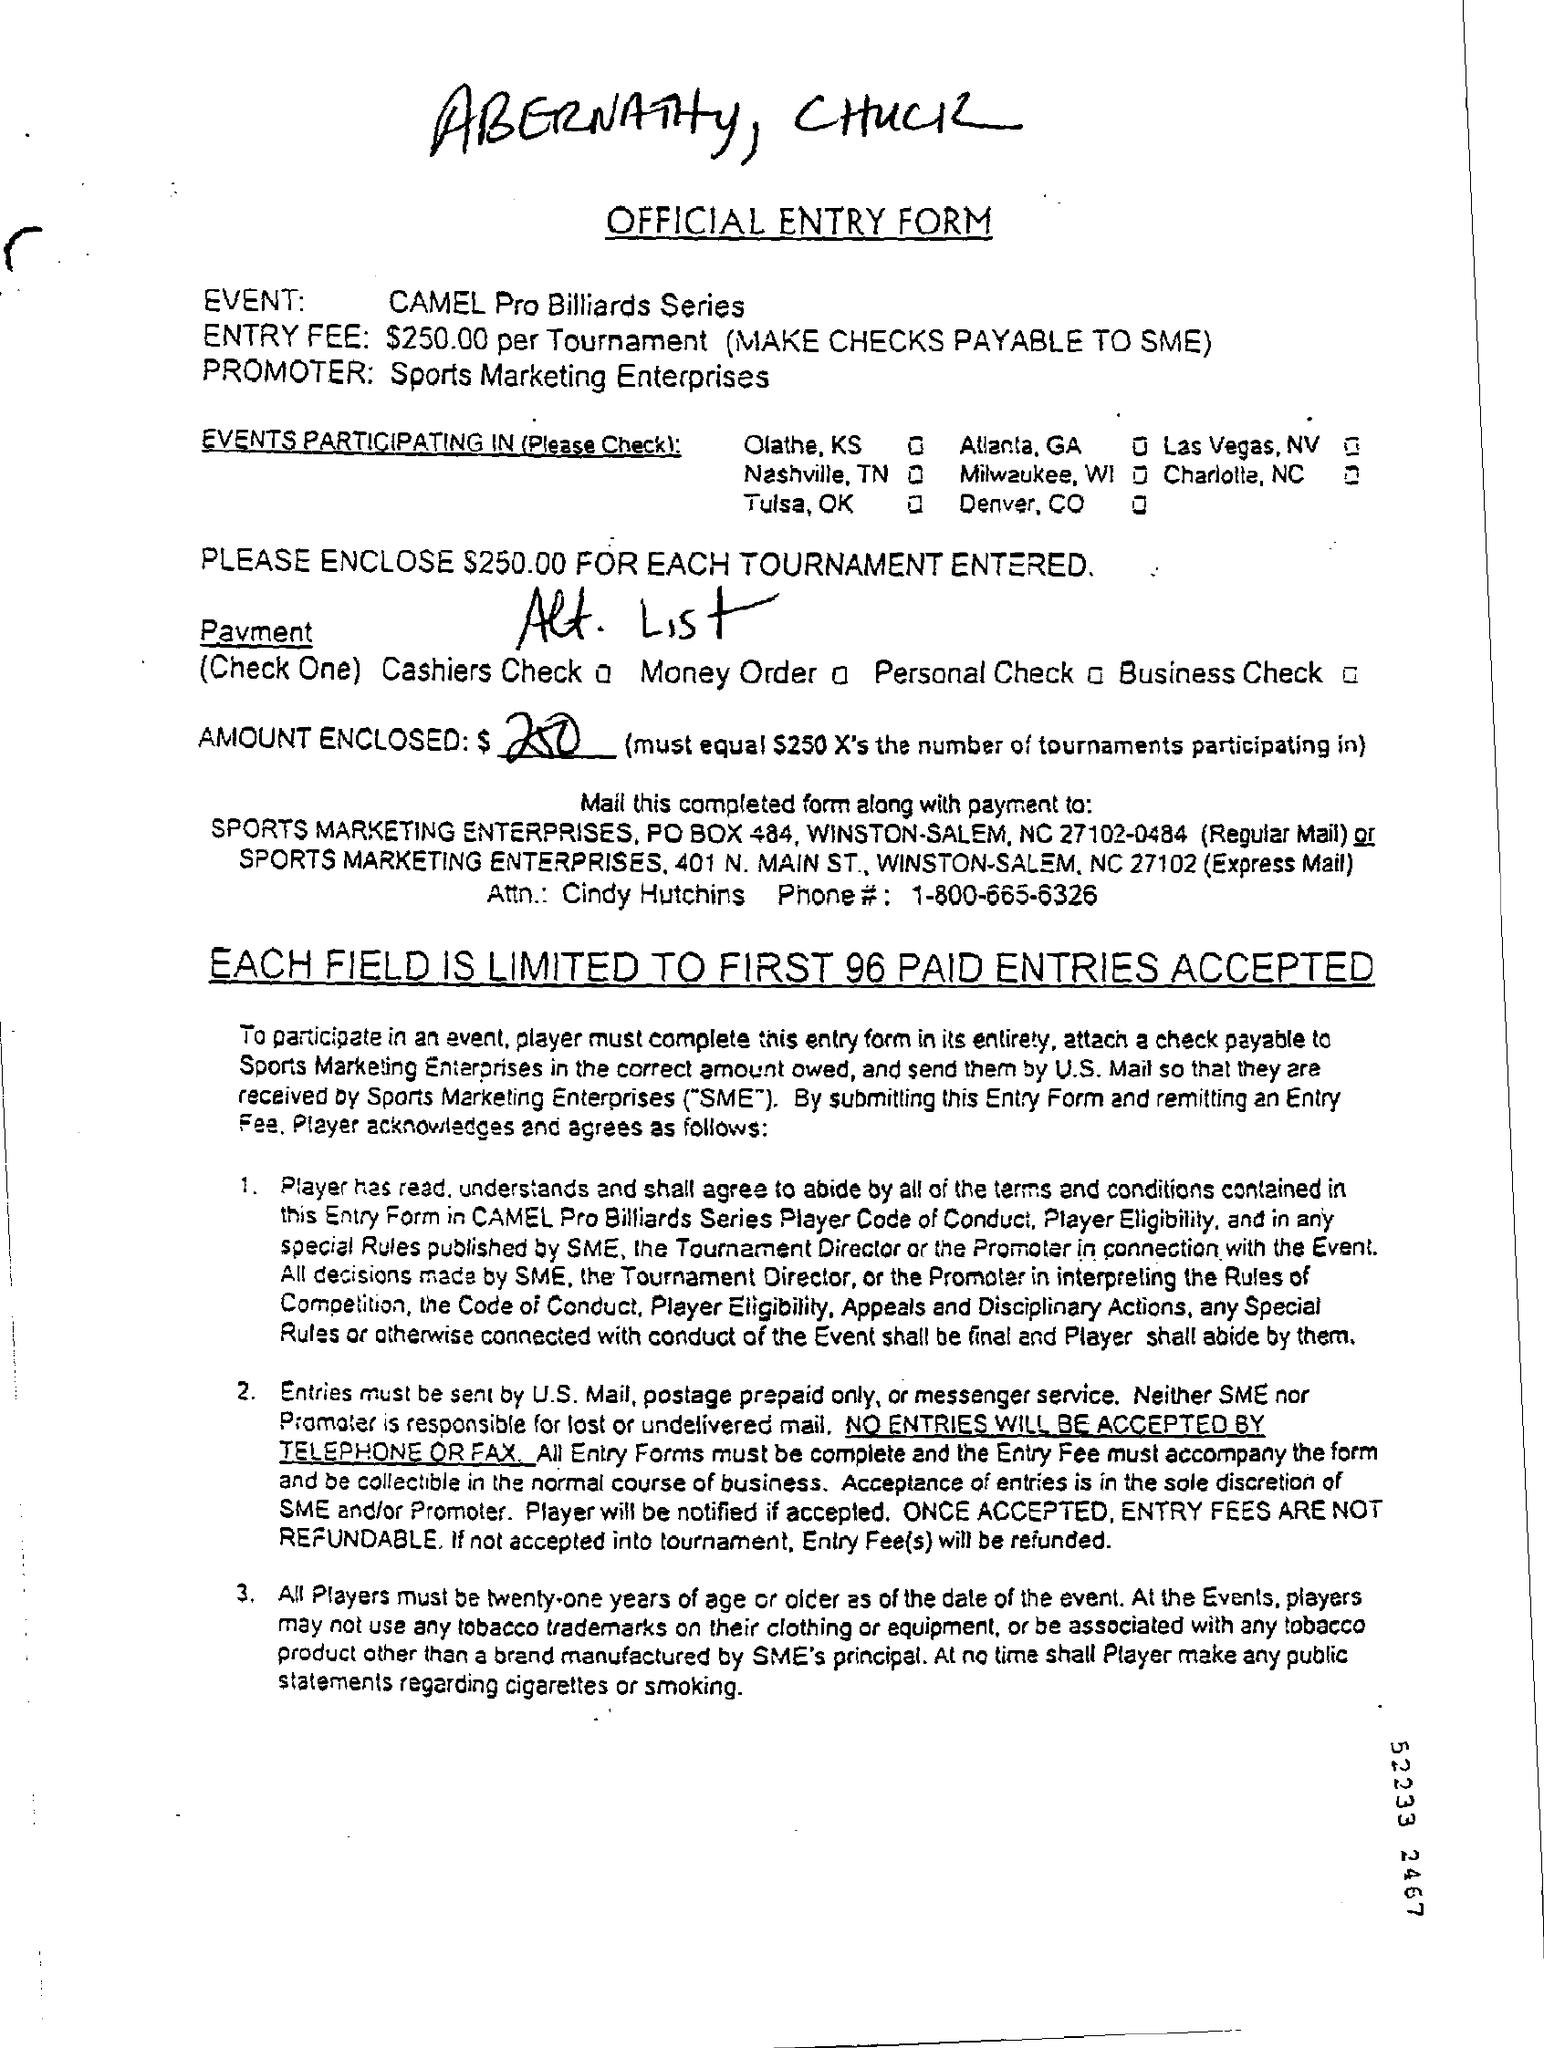Outline some significant characteristics in this image. The entry fee is $250.00. The event in question is the CAMEL Pro Billiards Series. The promoter of this event is Sports Marketing Enterprises. Entries will not be accepted via telephone or fax. 